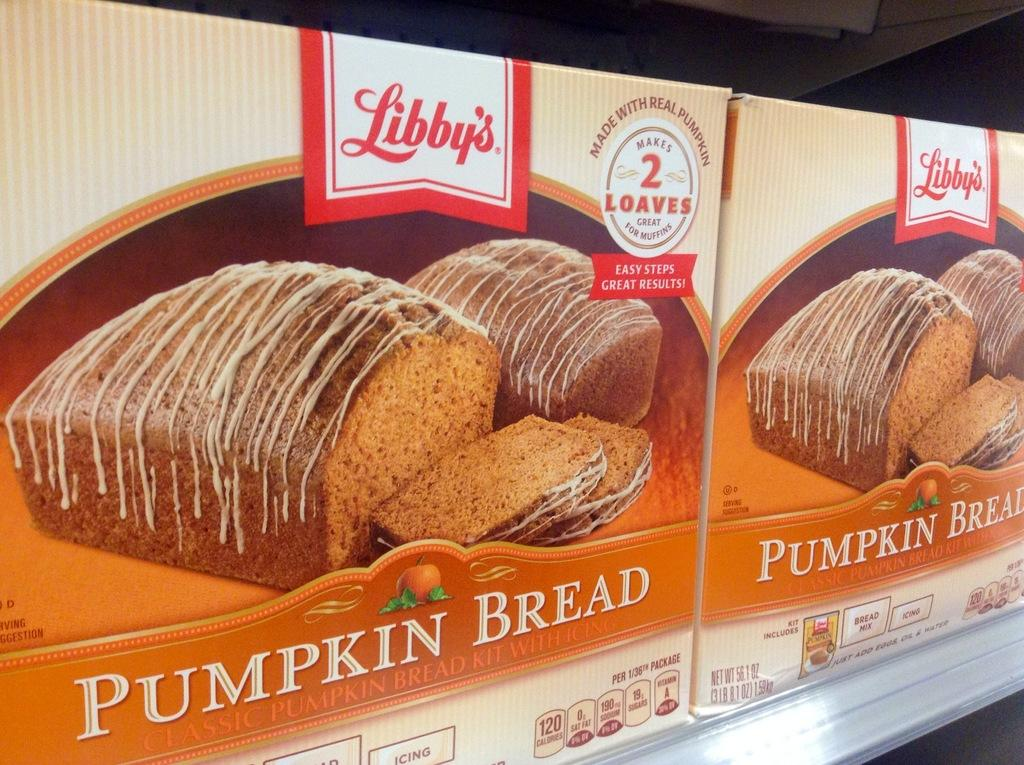What type of food is visible in the image? There are two pumpkin bread packets in the image. Where are the pumpkin bread packets located? The pumpkin bread packets are on a rack. What type of copper sticks can be seen in the image? There are no copper sticks present in the image. 